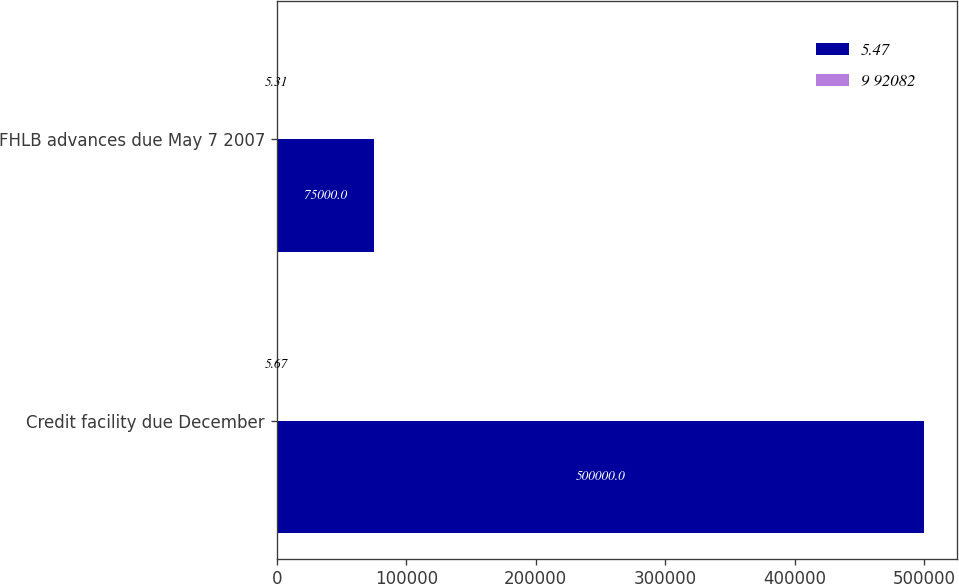Convert chart. <chart><loc_0><loc_0><loc_500><loc_500><stacked_bar_chart><ecel><fcel>Credit facility due December<fcel>FHLB advances due May 7 2007<nl><fcel>5.47<fcel>500000<fcel>75000<nl><fcel>9 92082<fcel>5.67<fcel>5.31<nl></chart> 